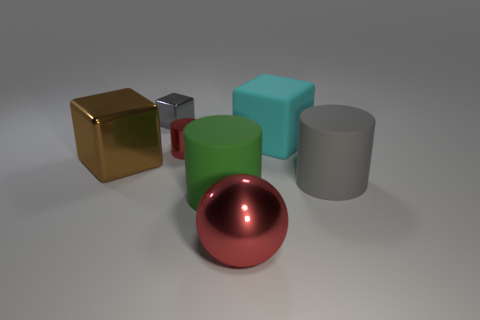Is the color of the metallic block behind the large brown metal object the same as the big cylinder that is right of the red shiny sphere?
Offer a terse response. Yes. What is the shape of the gray thing in front of the large metallic block?
Provide a succinct answer. Cylinder. The tiny metallic cylinder is what color?
Provide a succinct answer. Red. The gray thing that is made of the same material as the cyan object is what shape?
Give a very brief answer. Cylinder. There is a cylinder behind the brown cube; does it have the same size as the small gray thing?
Keep it short and to the point. Yes. What number of objects are either large objects that are right of the cyan cube or small cylinders left of the big cyan block?
Keep it short and to the point. 2. There is a big object in front of the green cylinder; does it have the same color as the metal cylinder?
Give a very brief answer. Yes. What number of rubber things are small cyan objects or small red things?
Offer a very short reply. 0. The big cyan object is what shape?
Give a very brief answer. Cube. Are the green thing and the big cyan block made of the same material?
Keep it short and to the point. Yes. 